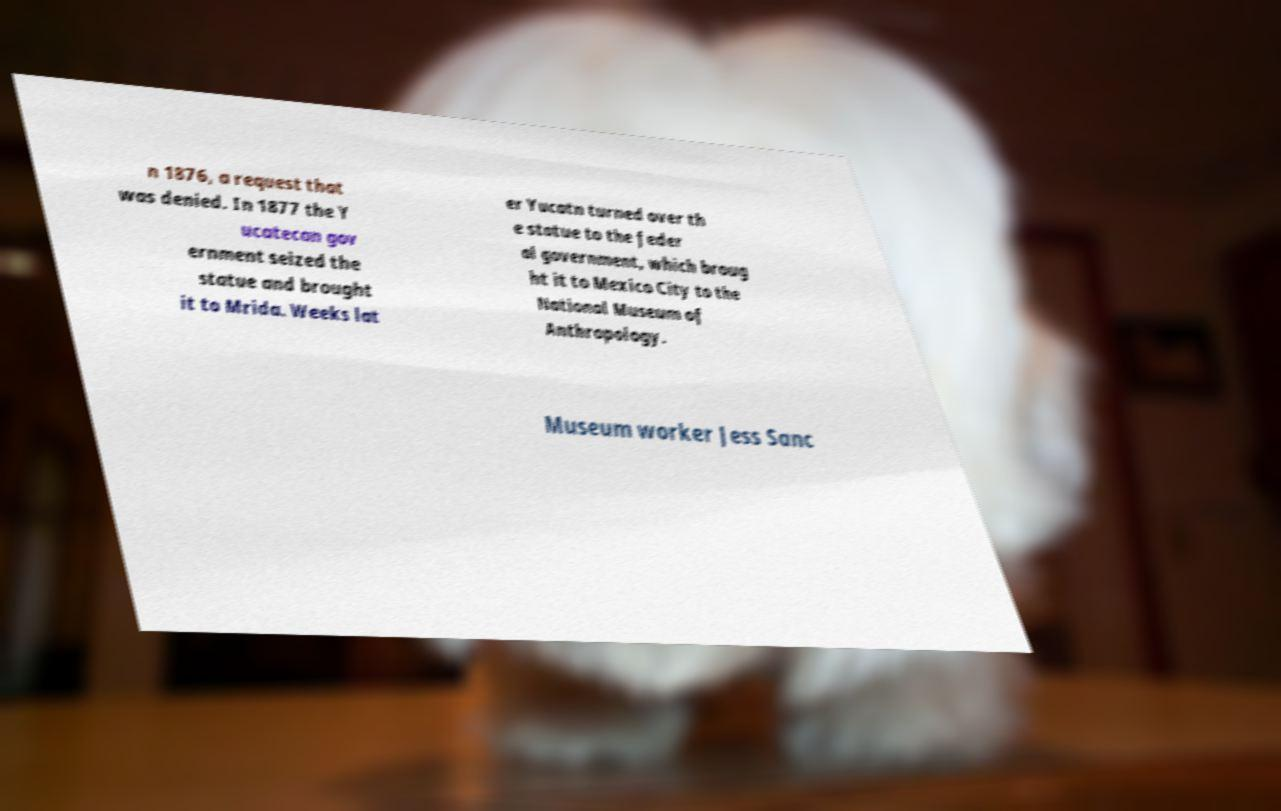Could you assist in decoding the text presented in this image and type it out clearly? n 1876, a request that was denied. In 1877 the Y ucatecan gov ernment seized the statue and brought it to Mrida. Weeks lat er Yucatn turned over th e statue to the feder al government, which broug ht it to Mexico City to the National Museum of Anthropology. Museum worker Jess Sanc 